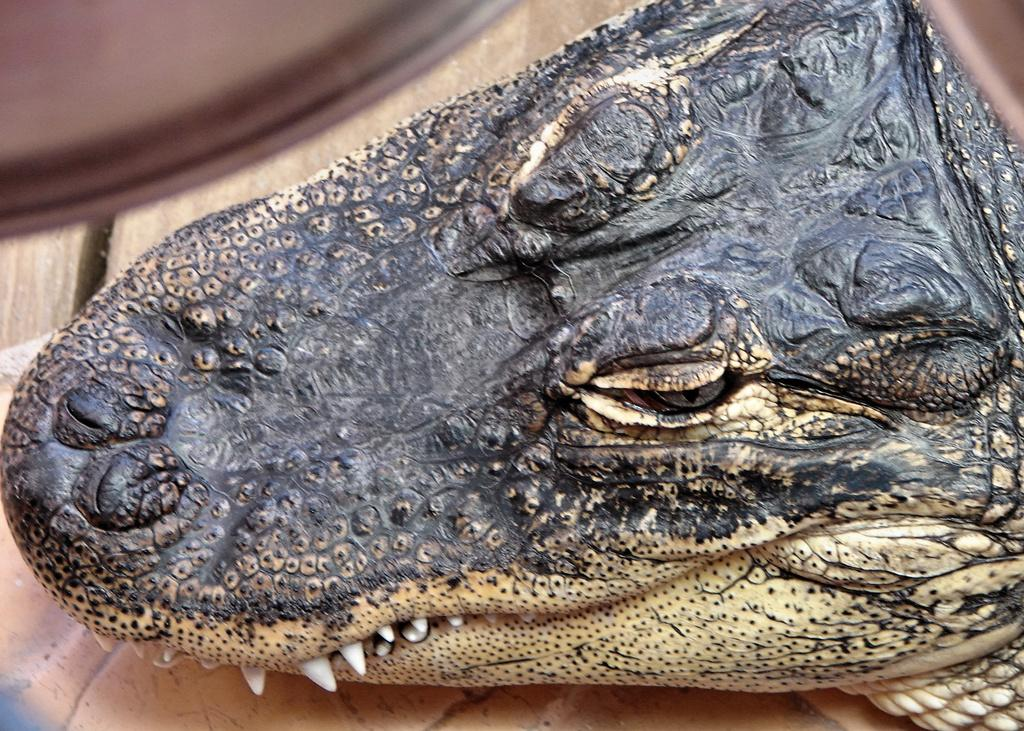What type of animal is in the image? There is an American alligator in the image. What type of leaf is being folded by the fireman in the image? There is no fireman or leaf present in the image; it features an American alligator. 